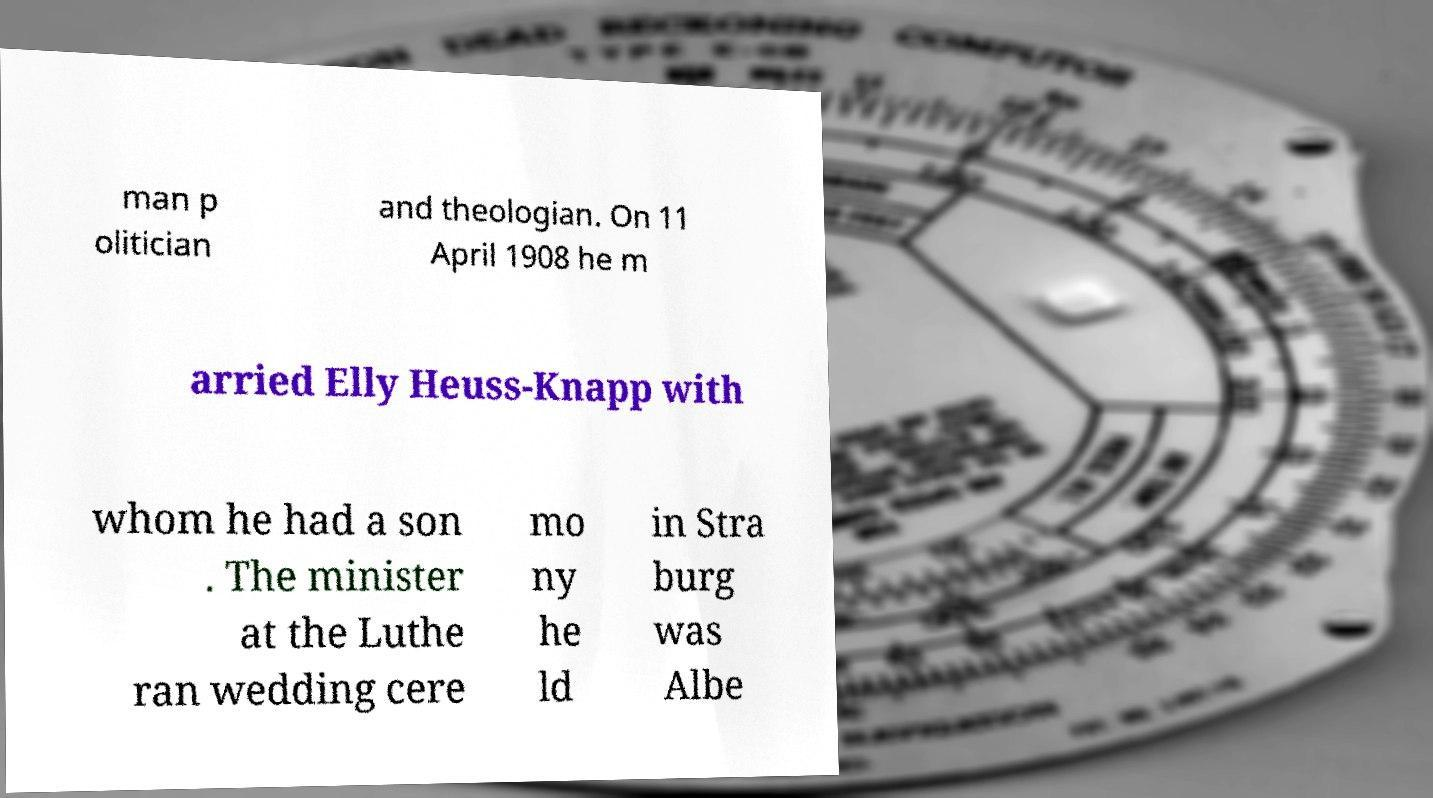I need the written content from this picture converted into text. Can you do that? man p olitician and theologian. On 11 April 1908 he m arried Elly Heuss-Knapp with whom he had a son . The minister at the Luthe ran wedding cere mo ny he ld in Stra burg was Albe 